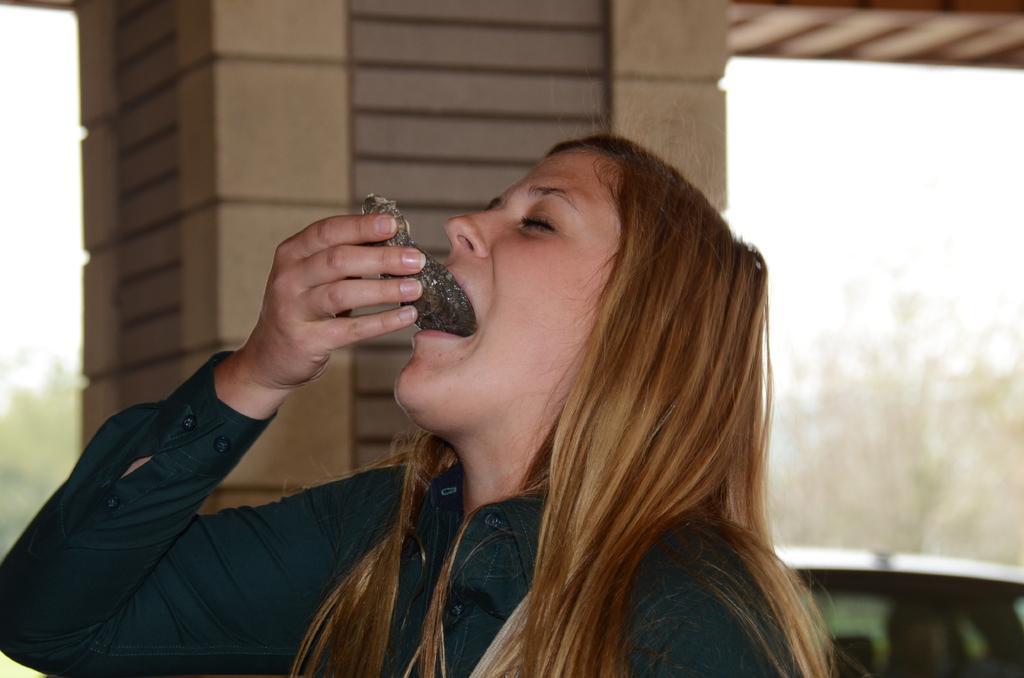Could you give a brief overview of what you see in this image? In this image we can see a person standing and eating a food item. And we can see a pillar and blur background. 